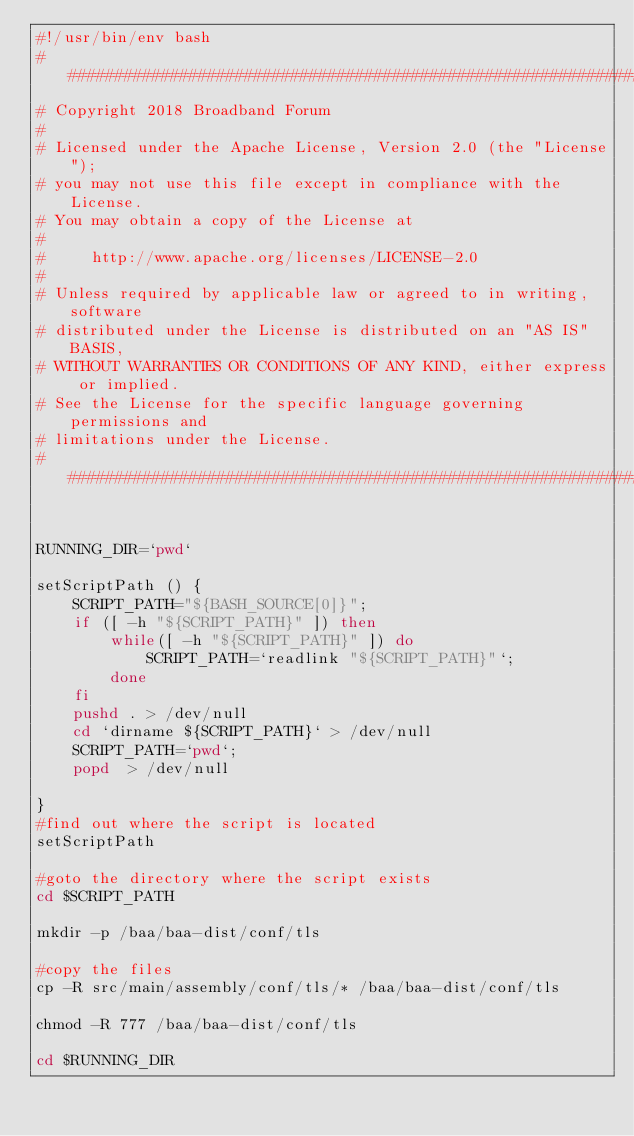<code> <loc_0><loc_0><loc_500><loc_500><_Bash_>#!/usr/bin/env bash
###########################################################################
# Copyright 2018 Broadband Forum
#
# Licensed under the Apache License, Version 2.0 (the "License");
# you may not use this file except in compliance with the License.
# You may obtain a copy of the License at
#
#     http://www.apache.org/licenses/LICENSE-2.0
#
# Unless required by applicable law or agreed to in writing, software
# distributed under the License is distributed on an "AS IS" BASIS,
# WITHOUT WARRANTIES OR CONDITIONS OF ANY KIND, either express or implied.
# See the License for the specific language governing permissions and
# limitations under the License.
###########################################################################


RUNNING_DIR=`pwd`

setScriptPath () {
    SCRIPT_PATH="${BASH_SOURCE[0]}";
    if ([ -h "${SCRIPT_PATH}" ]) then
        while([ -h "${SCRIPT_PATH}" ]) do
            SCRIPT_PATH=`readlink "${SCRIPT_PATH}"`;
        done
    fi
    pushd . > /dev/null
    cd `dirname ${SCRIPT_PATH}` > /dev/null
    SCRIPT_PATH=`pwd`;
    popd  > /dev/null

}
#find out where the script is located
setScriptPath

#goto the directory where the script exists
cd $SCRIPT_PATH

mkdir -p /baa/baa-dist/conf/tls

#copy the files
cp -R src/main/assembly/conf/tls/* /baa/baa-dist/conf/tls

chmod -R 777 /baa/baa-dist/conf/tls

cd $RUNNING_DIR
</code> 